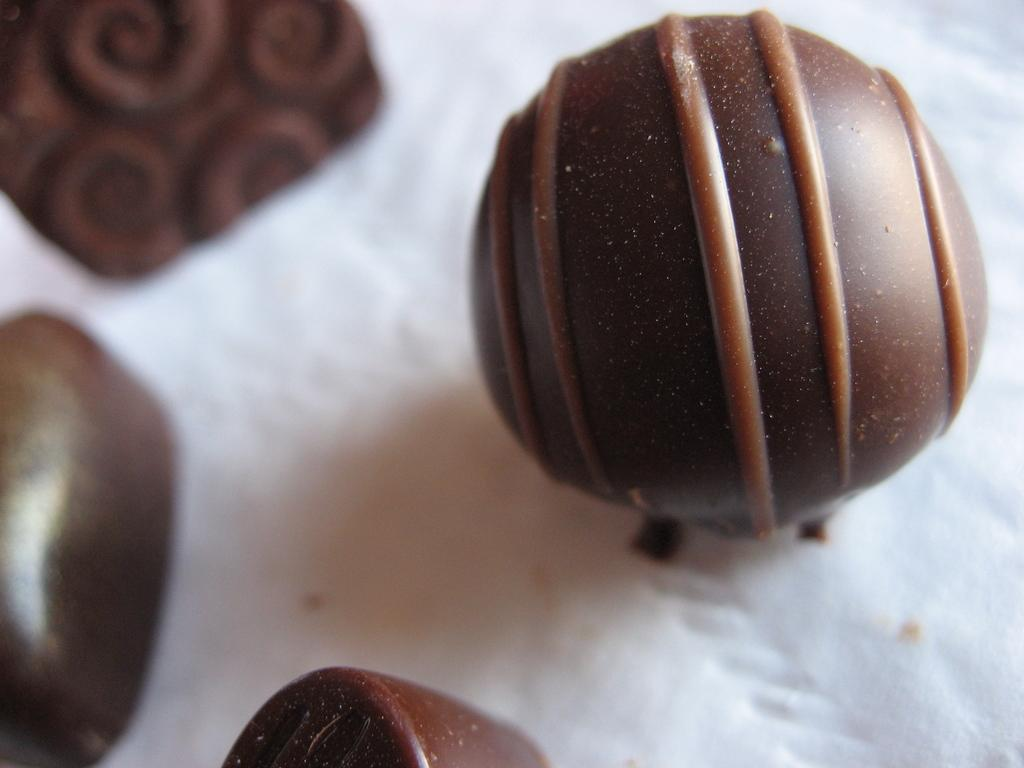What type of food is present in the image? There is chocolate in the image. What is the color of the chocolate? The chocolate is brown in color. What is on the surface of the chocolate? There is some paste on the chocolate. On what is the chocolate placed? The chocolate is placed on a white-colored tissue. How many brothers are depicted in the image? There are no people, including brothers, present in the image. What type of arithmetic problem is being solved on the chocolate? There is no arithmetic problem present on the chocolate; it has paste on its surface. 